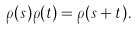<formula> <loc_0><loc_0><loc_500><loc_500>\rho ( s ) \rho ( t ) = \rho ( s + t ) .</formula> 